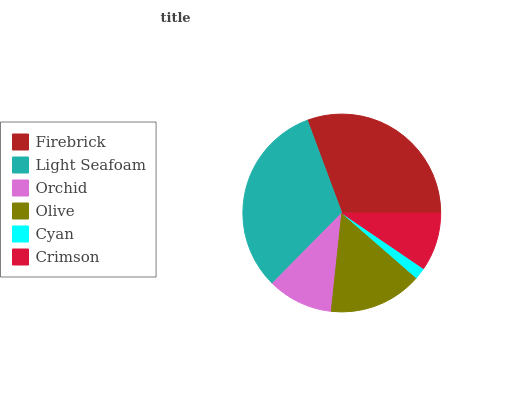Is Cyan the minimum?
Answer yes or no. Yes. Is Light Seafoam the maximum?
Answer yes or no. Yes. Is Orchid the minimum?
Answer yes or no. No. Is Orchid the maximum?
Answer yes or no. No. Is Light Seafoam greater than Orchid?
Answer yes or no. Yes. Is Orchid less than Light Seafoam?
Answer yes or no. Yes. Is Orchid greater than Light Seafoam?
Answer yes or no. No. Is Light Seafoam less than Orchid?
Answer yes or no. No. Is Olive the high median?
Answer yes or no. Yes. Is Orchid the low median?
Answer yes or no. Yes. Is Light Seafoam the high median?
Answer yes or no. No. Is Cyan the low median?
Answer yes or no. No. 